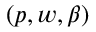<formula> <loc_0><loc_0><loc_500><loc_500>( p , w , \beta )</formula> 